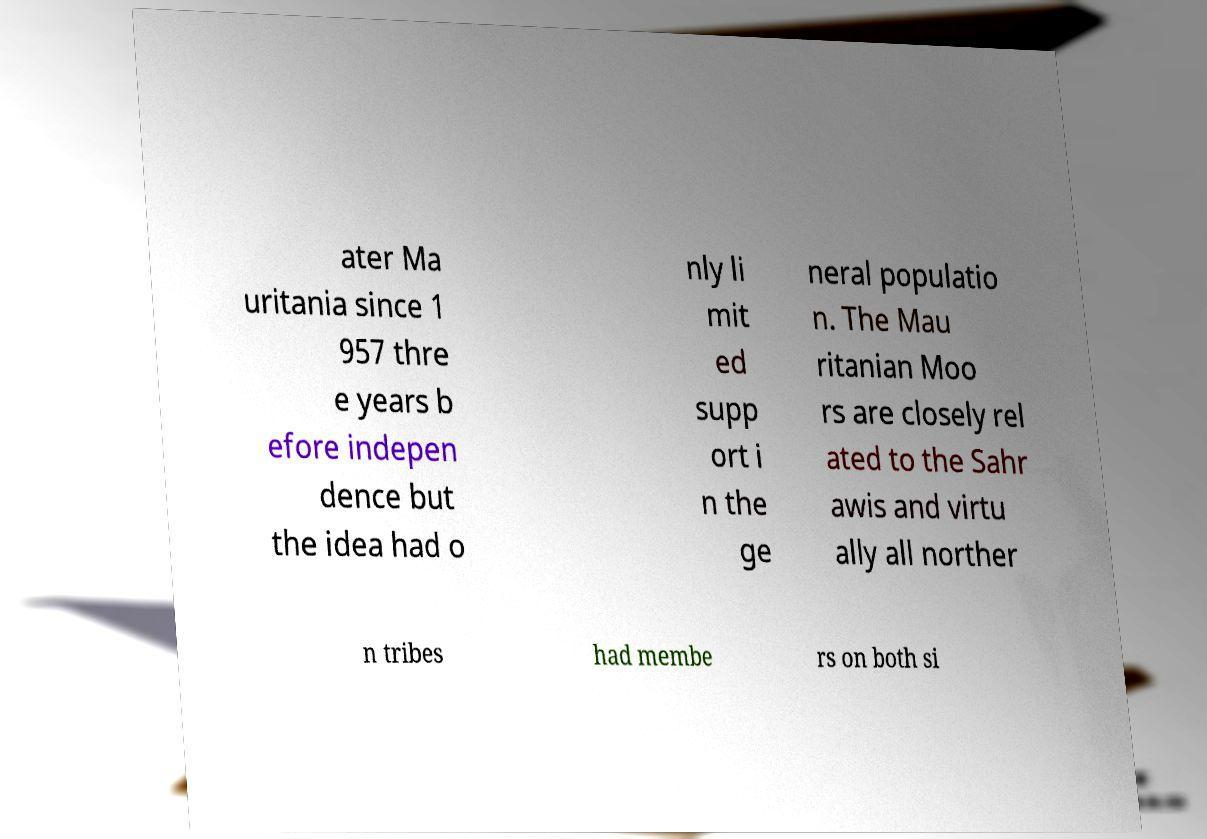For documentation purposes, I need the text within this image transcribed. Could you provide that? ater Ma uritania since 1 957 thre e years b efore indepen dence but the idea had o nly li mit ed supp ort i n the ge neral populatio n. The Mau ritanian Moo rs are closely rel ated to the Sahr awis and virtu ally all norther n tribes had membe rs on both si 